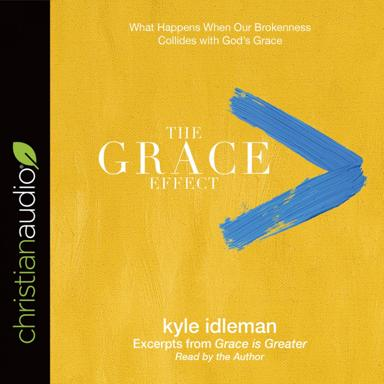What is the name of the work mentioned in the image?
 The work mentioned in the image is "The Grace Effect" and it features excerpts from "Grace is Greater" by Kyle Idleman. How is the work presented according to the image? The work is presented as an audio format, with excerpts from "Grace is Greater" read by the author, Kyle Idleman, via christianaudio. What is the central theme of "The Grace Effect"? The central theme of "The Grace Effect" is what happens when our brokenness collides with God's grace, emphasizing the transformative power of God's grace in people's lives. 